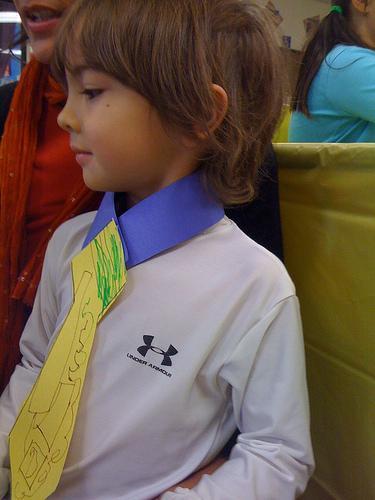How many children?
Give a very brief answer. 1. 